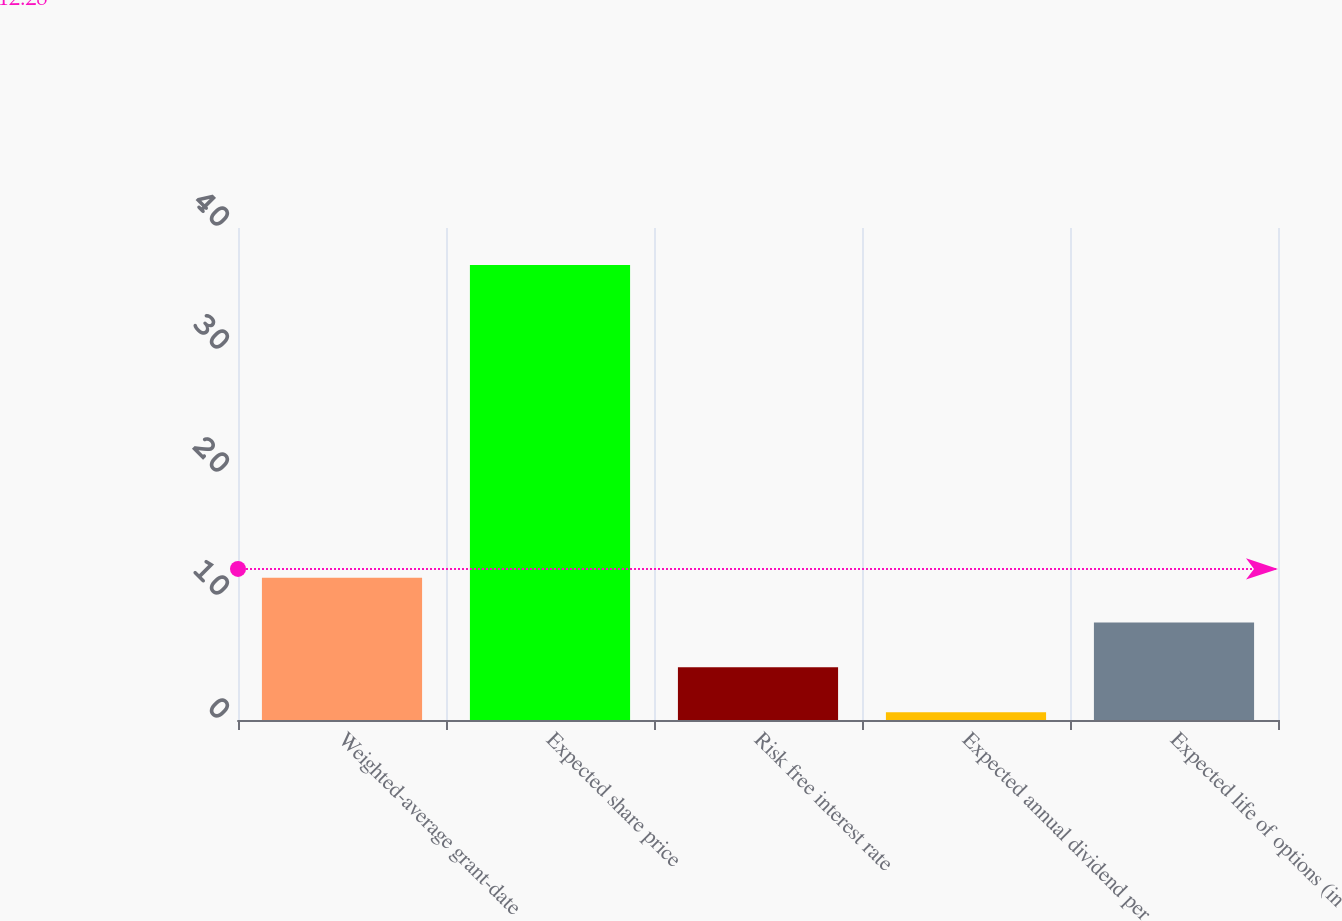Convert chart to OTSL. <chart><loc_0><loc_0><loc_500><loc_500><bar_chart><fcel>Weighted-average grant-date<fcel>Expected share price<fcel>Risk free interest rate<fcel>Expected annual dividend per<fcel>Expected life of options (in<nl><fcel>11.56<fcel>37<fcel>4.28<fcel>0.64<fcel>7.92<nl></chart> 